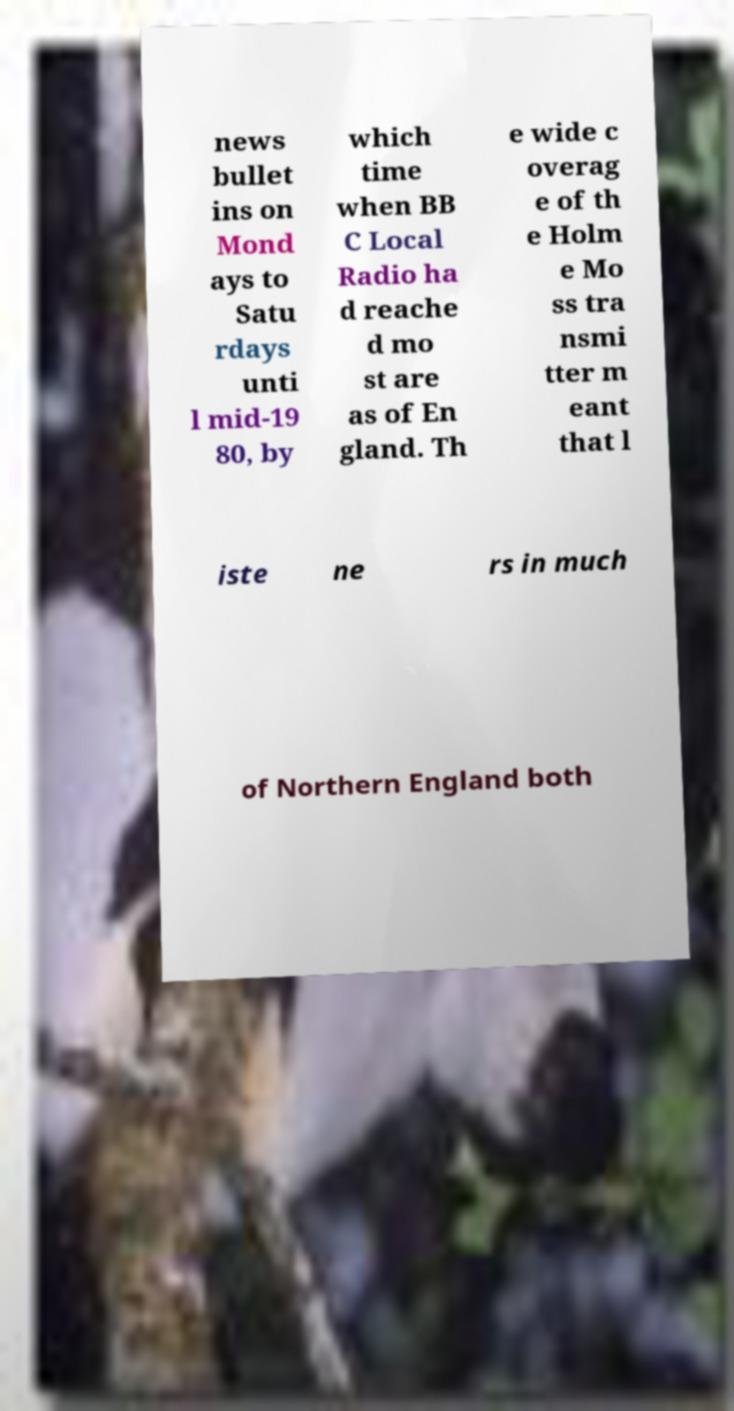I need the written content from this picture converted into text. Can you do that? news bullet ins on Mond ays to Satu rdays unti l mid-19 80, by which time when BB C Local Radio ha d reache d mo st are as of En gland. Th e wide c overag e of th e Holm e Mo ss tra nsmi tter m eant that l iste ne rs in much of Northern England both 